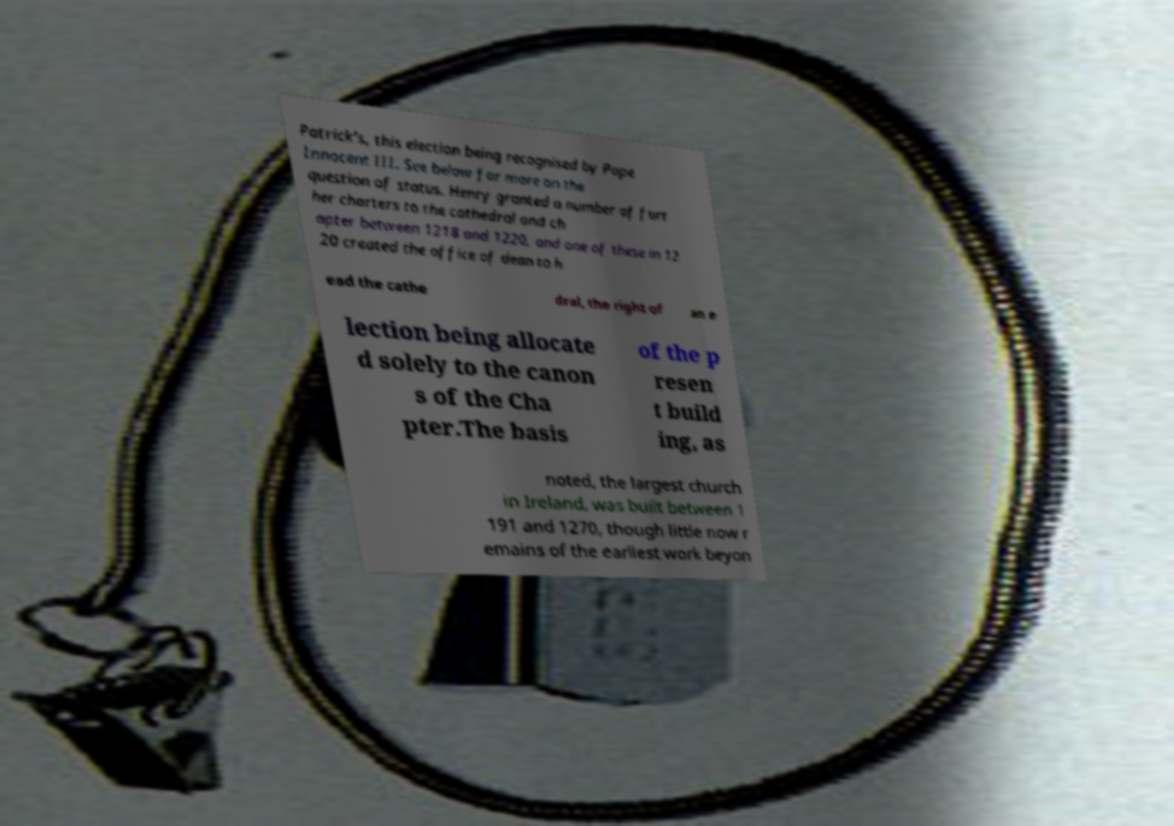There's text embedded in this image that I need extracted. Can you transcribe it verbatim? Patrick's, this election being recognised by Pope Innocent III. See below for more on the question of status. Henry granted a number of furt her charters to the cathedral and ch apter between 1218 and 1220, and one of these in 12 20 created the office of dean to h ead the cathe dral, the right of an e lection being allocate d solely to the canon s of the Cha pter.The basis of the p resen t build ing, as noted, the largest church in Ireland, was built between 1 191 and 1270, though little now r emains of the earliest work beyon 